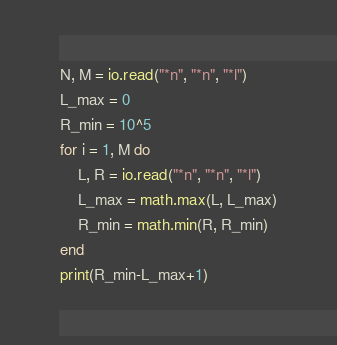<code> <loc_0><loc_0><loc_500><loc_500><_Lua_>N, M = io.read("*n", "*n", "*l")
L_max = 0
R_min = 10^5
for i = 1, M do
    L, R = io.read("*n", "*n", "*l")
    L_max = math.max(L, L_max)
    R_min = math.min(R, R_min)
end
print(R_min-L_max+1)</code> 